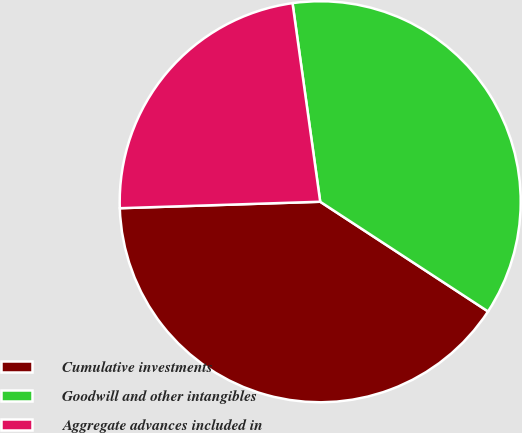<chart> <loc_0><loc_0><loc_500><loc_500><pie_chart><fcel>Cumulative investments<fcel>Goodwill and other intangibles<fcel>Aggregate advances included in<nl><fcel>40.27%<fcel>36.42%<fcel>23.31%<nl></chart> 